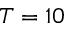Convert formula to latex. <formula><loc_0><loc_0><loc_500><loc_500>T = 1 0</formula> 